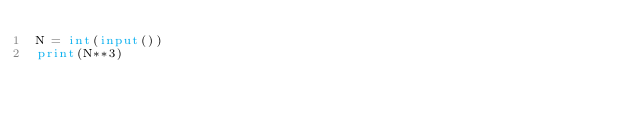Convert code to text. <code><loc_0><loc_0><loc_500><loc_500><_Python_>N = int(input())
print(N**3)
</code> 